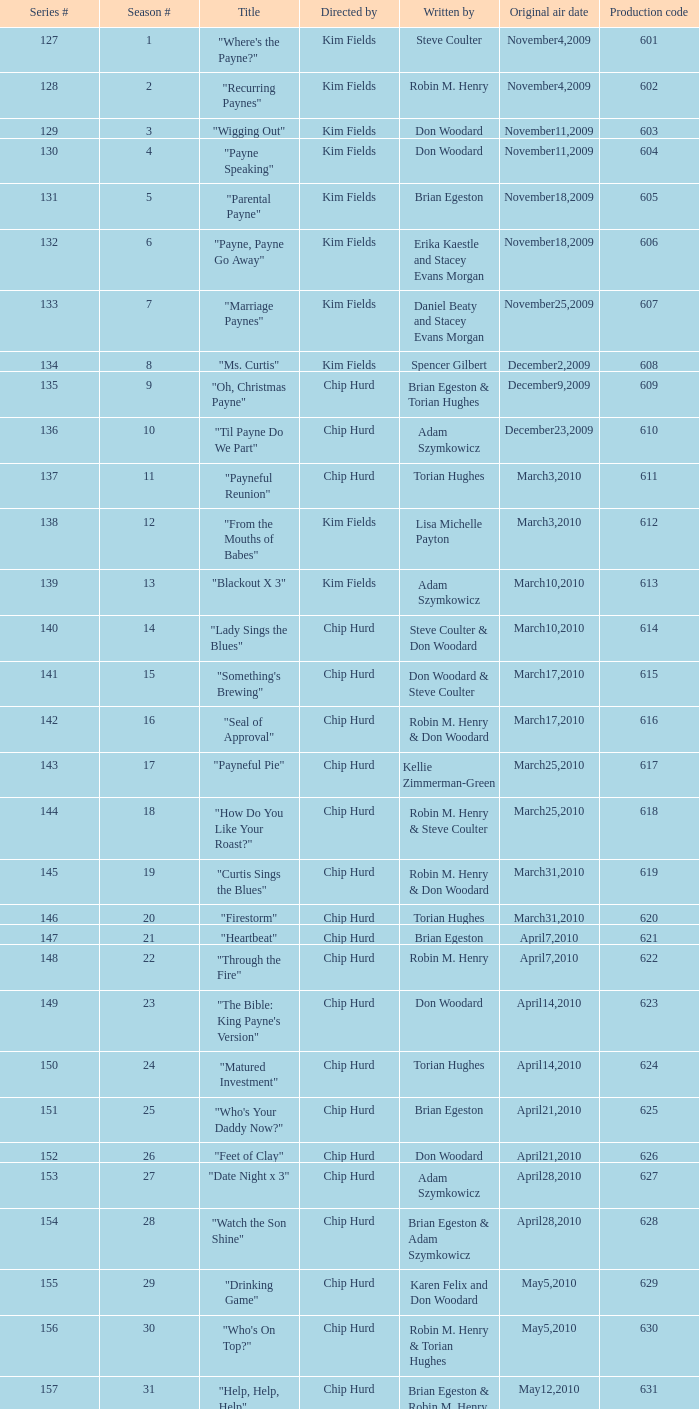What is the original broadcast dates for the title "firestorm"? March31,2010. 